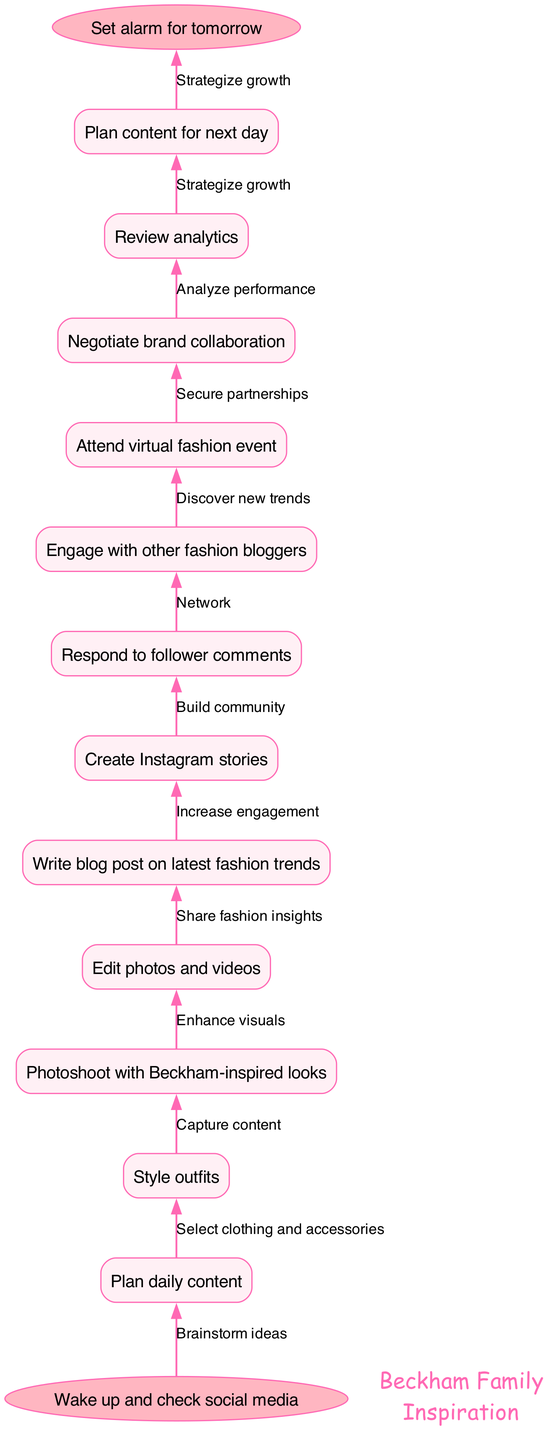What's the starting activity of the fashion blogger's daily routine? The diagram indicates that the starting activity is specifically stated as "Wake up and check social media". This direct description is found at the top or initial point of the flowchart.
Answer: Wake up and check social media How many main nodes are there in the routine? To determine the number of nodes, I count each main activity listed in the nodes section of the diagram. There are 12 nodes, which include planning, styling, photoshooting, editing, writing, creating stories, responding to comments, engaging, attending, negotiating, reviewing, and planning next day.
Answer: 12 What is the last activity before the end of the routine? The final activity in the flow of the diagram is found by looking at the last node connected before reaching the end. The last main node listed prior to “Set alarm for tomorrow” is “Plan content for next day”.
Answer: Plan content for next day Which node involves follower interaction? I identify the nodes related to interaction by reviewing the list. Among them, “Respond to follower comments” and “Engage with other fashion bloggers” involve directly interacting with followers and peers in the influencer community.
Answer: Respond to follower comments What is the relationship between the "Photoshoot with Beckham-inspired looks" and "Edit photos and videos"? The diagram shows a direct edge connecting the "Photoshoot with Beckham-inspired looks" to "Edit photos and videos". This represents a sequential process where after capturing content in a photoshoot, the next logical step is editing it.
Answer: Capture content 